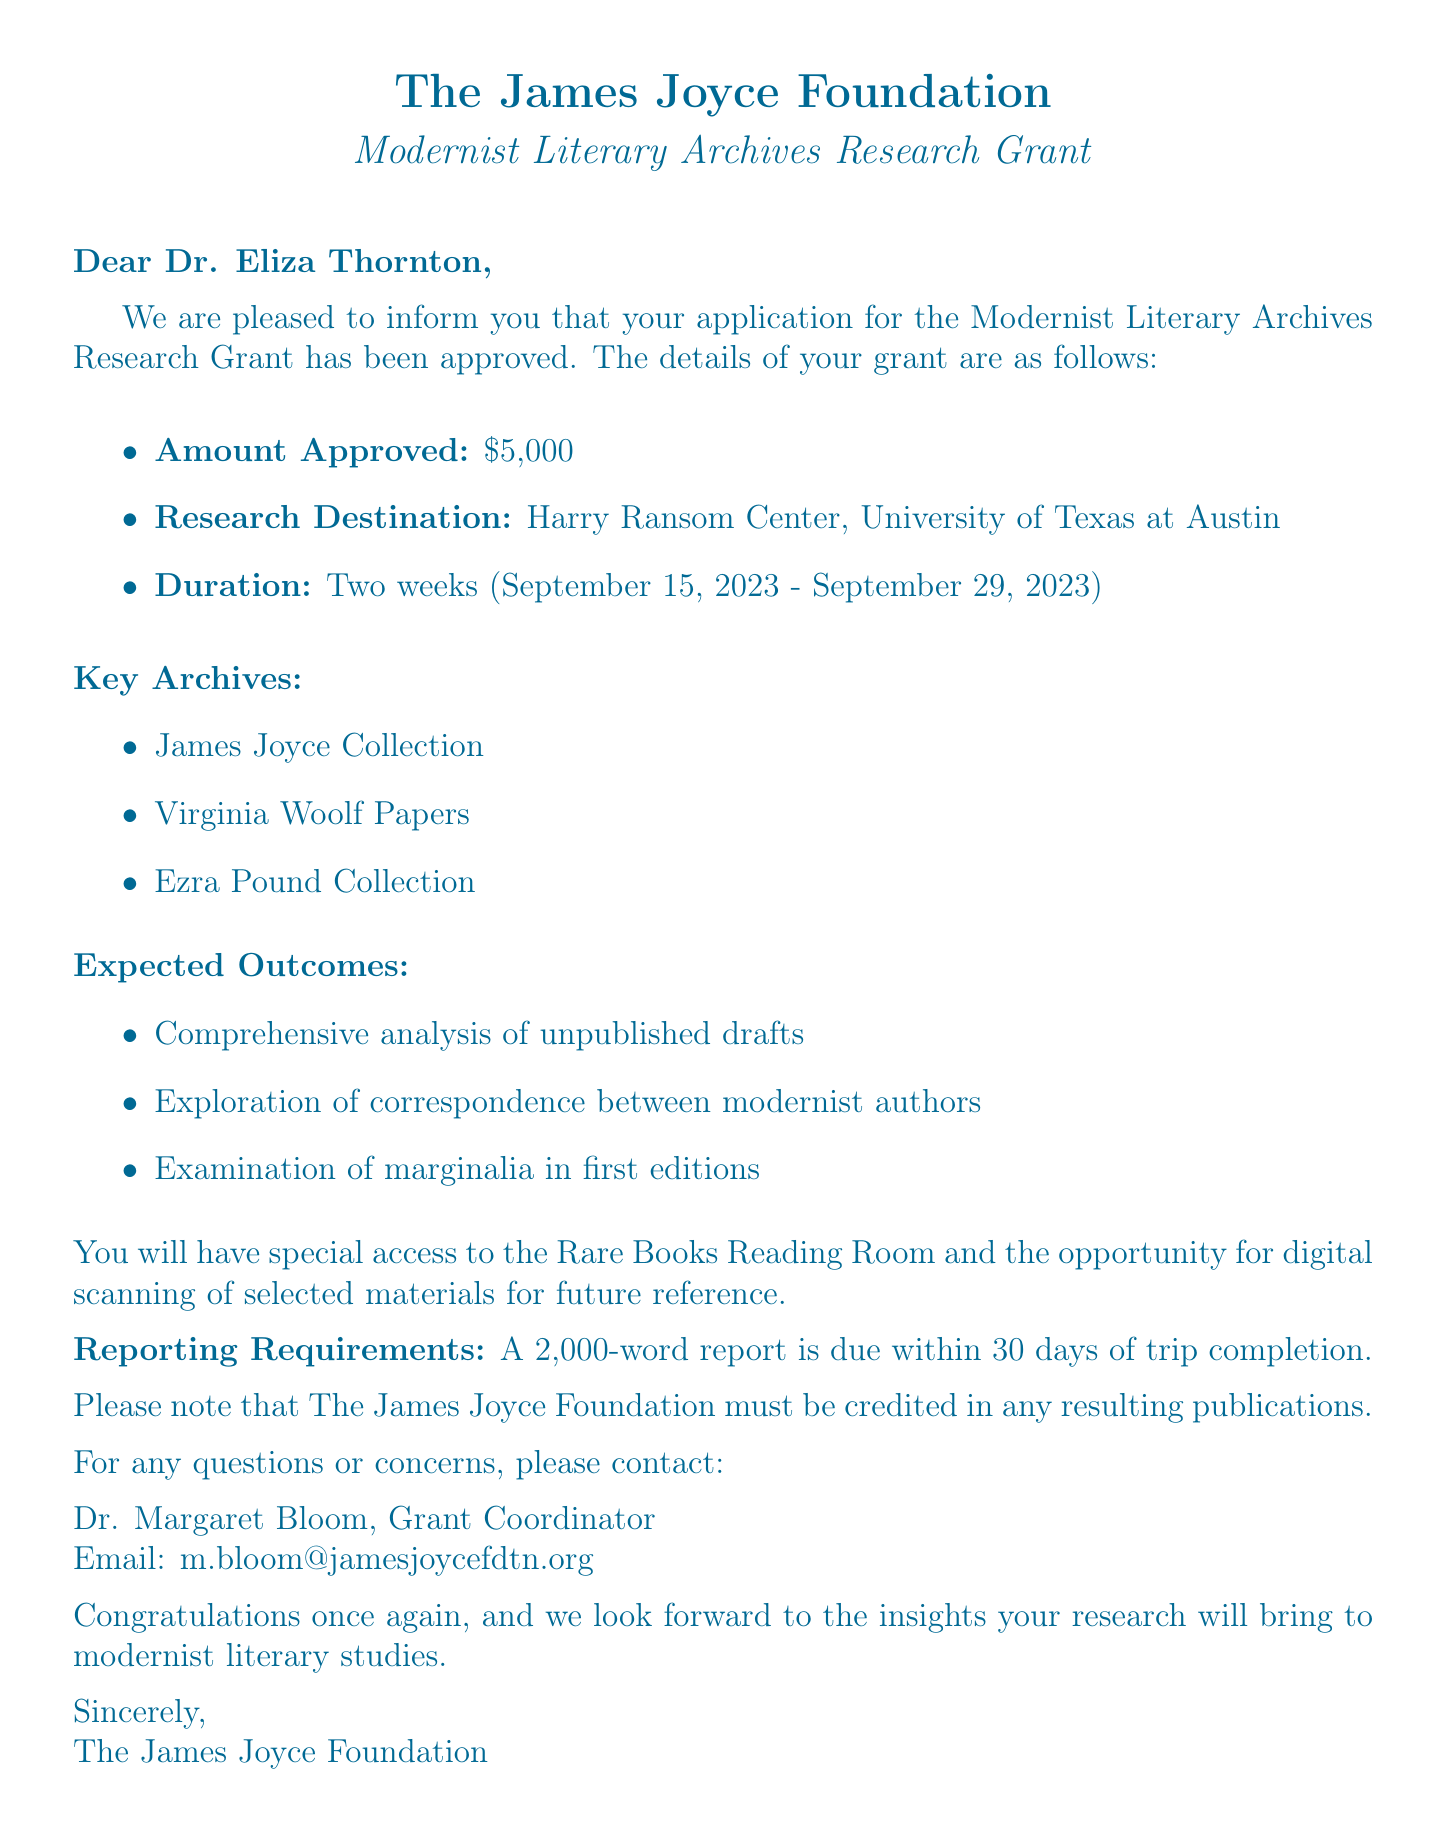What is the name of the grant? The document states the name of the grant as the Modernist Literary Archives Research Grant.
Answer: Modernist Literary Archives Research Grant Who is the recipient of the grant? The document mentions the recipient's name as Dr. Eliza Thornton.
Answer: Dr. Eliza Thornton What is the amount approved for the grant? The document specifies that the amount approved is $5,000.
Answer: $5,000 What is the research destination? According to the document, the research destination is the Harry Ransom Center, University of Texas at Austin.
Answer: Harry Ransom Center, University of Texas at Austin What are the expected outcomes of the research? The document lists three expected outcomes including a comprehensive analysis of unpublished drafts, exploration of correspondence between modernist authors, and examination of marginalia in first editions.
Answer: Comprehensive analysis of unpublished drafts, exploration of correspondence between modernist authors, examination of marginalia in first editions How long is the duration of the research trip? The document indicates that the duration of the research trip is two weeks.
Answer: Two weeks Who should be credited in resulting publications? The document states that The James Joyce Foundation must be credited in any resulting publications.
Answer: The James Joyce Foundation What is the due date for the report? The document specifies that the report is due within 30 days of trip completion.
Answer: 30 days of trip completion 